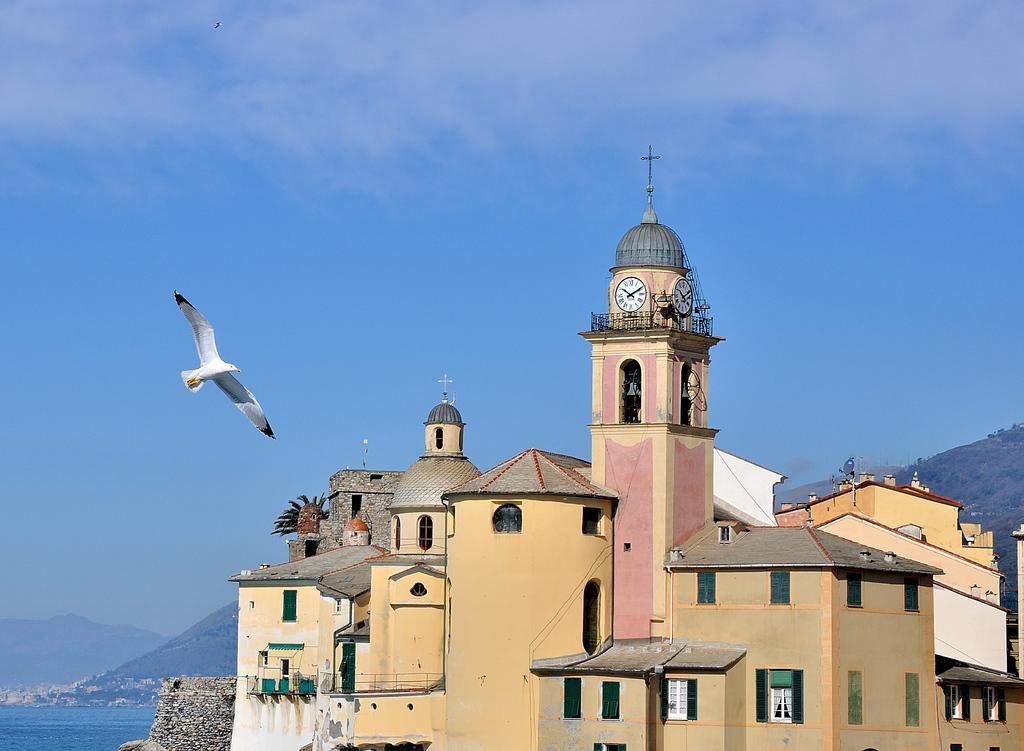What is flying in the air in the image? There is a bird in the air in the image. What can be seen on the building in the image? There are clocks on a building in the image. What type of structures are visible in the image? There are buildings visible in the image. What type of natural landscape can be seen in the image? There are hills visible in the image. What body of water is present in the image? There is water visible in the image. What type of twig is the bird holding in its beak in the image? There is no twig visible in the image; the bird is simply flying in the air. 